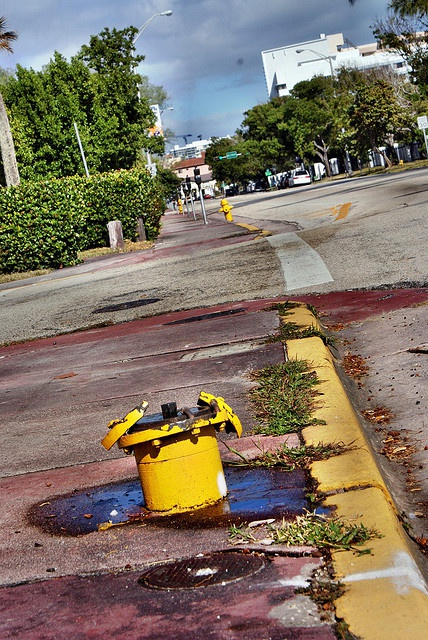Describe the objects in this image and their specific colors. I can see fire hydrant in darkgray, gold, black, orange, and maroon tones, car in darkgray, white, black, and gray tones, fire hydrant in darkgray, gold, orange, khaki, and olive tones, parking meter in darkgray, black, gray, and lightgray tones, and fire hydrant in darkgray, orange, gold, and olive tones in this image. 